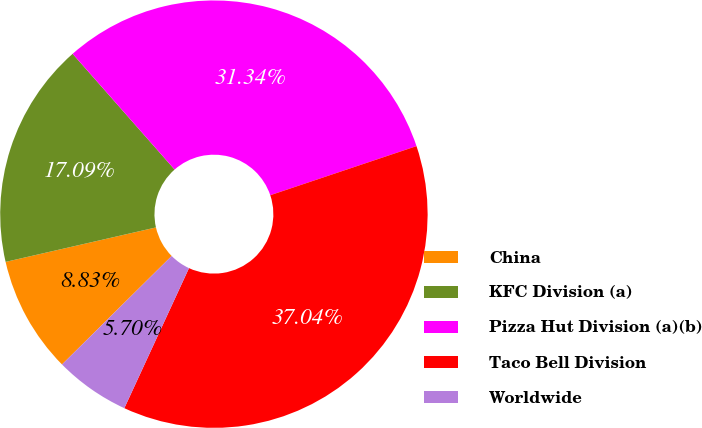Convert chart to OTSL. <chart><loc_0><loc_0><loc_500><loc_500><pie_chart><fcel>China<fcel>KFC Division (a)<fcel>Pizza Hut Division (a)(b)<fcel>Taco Bell Division<fcel>Worldwide<nl><fcel>8.83%<fcel>17.09%<fcel>31.34%<fcel>37.04%<fcel>5.7%<nl></chart> 